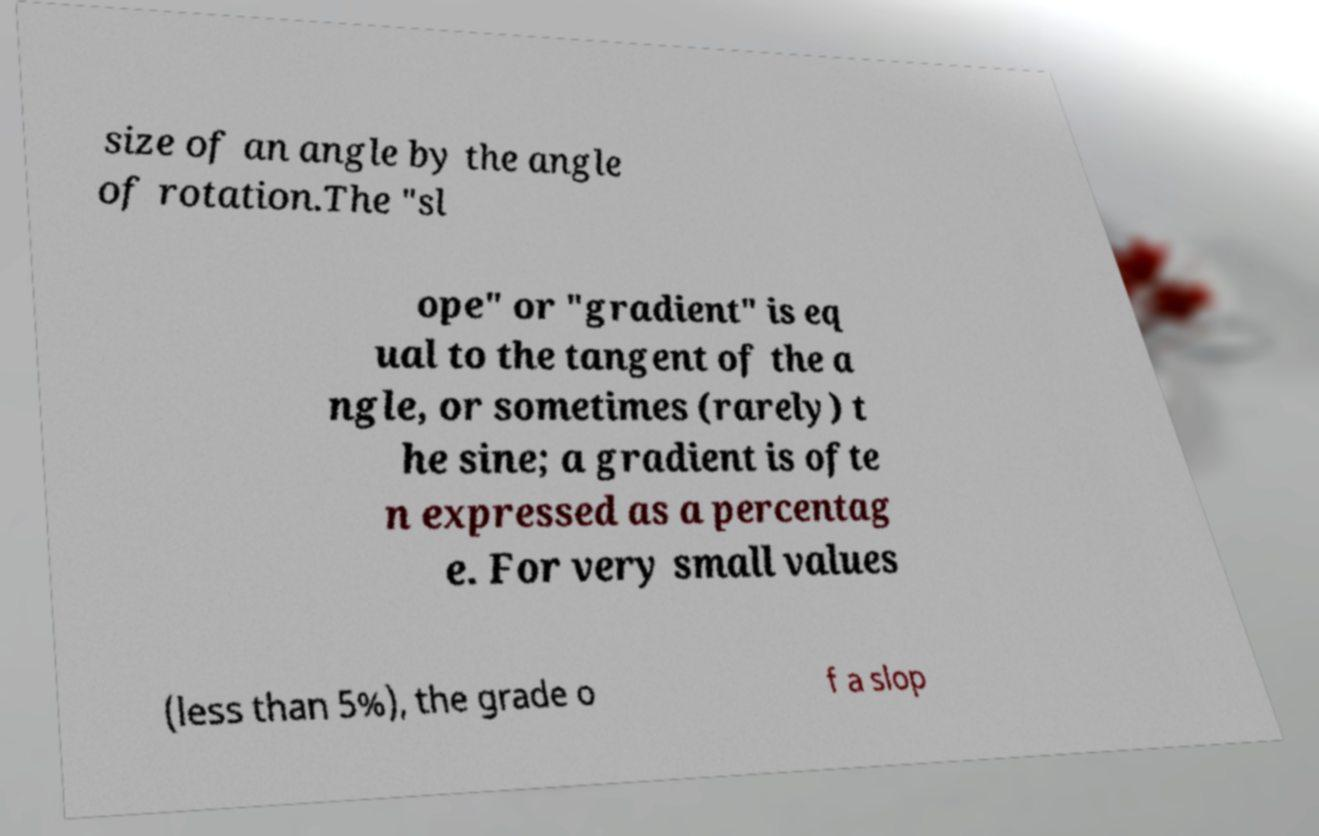Can you read and provide the text displayed in the image?This photo seems to have some interesting text. Can you extract and type it out for me? size of an angle by the angle of rotation.The "sl ope" or "gradient" is eq ual to the tangent of the a ngle, or sometimes (rarely) t he sine; a gradient is ofte n expressed as a percentag e. For very small values (less than 5%), the grade o f a slop 